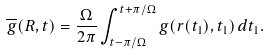<formula> <loc_0><loc_0><loc_500><loc_500>\overline { g } ( { R } , t ) = \frac { \Omega } { 2 \pi } \int _ { t - \pi / \Omega } ^ { t + \pi / \Omega } g ( { r } ( t _ { 1 } ) , t _ { 1 } ) \, d t _ { 1 } .</formula> 